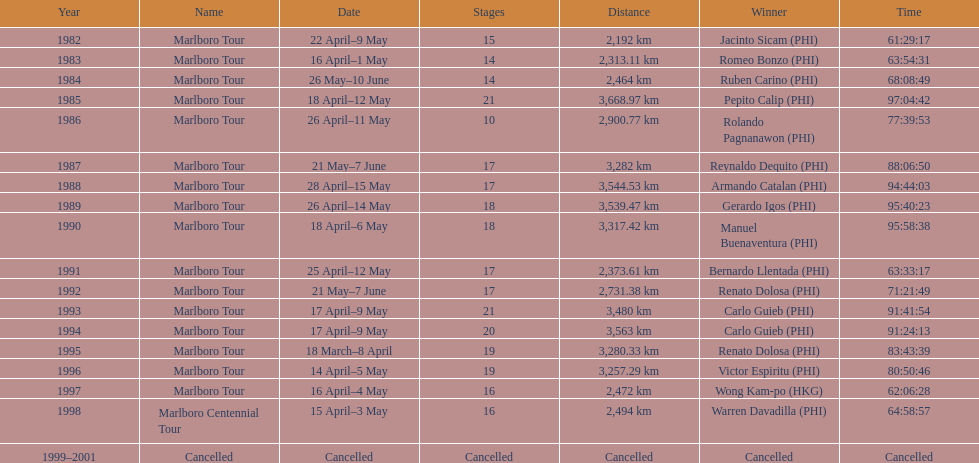Who achieved the most wins in marlboro tours? Carlo Guieb. Can you parse all the data within this table? {'header': ['Year', 'Name', 'Date', 'Stages', 'Distance', 'Winner', 'Time'], 'rows': [['1982', 'Marlboro Tour', '22 April–9 May', '15', '2,192\xa0km', 'Jacinto Sicam\xa0(PHI)', '61:29:17'], ['1983', 'Marlboro Tour', '16 April–1 May', '14', '2,313.11\xa0km', 'Romeo Bonzo\xa0(PHI)', '63:54:31'], ['1984', 'Marlboro Tour', '26 May–10 June', '14', '2,464\xa0km', 'Ruben Carino\xa0(PHI)', '68:08:49'], ['1985', 'Marlboro Tour', '18 April–12 May', '21', '3,668.97\xa0km', 'Pepito Calip\xa0(PHI)', '97:04:42'], ['1986', 'Marlboro Tour', '26 April–11 May', '10', '2,900.77\xa0km', 'Rolando Pagnanawon\xa0(PHI)', '77:39:53'], ['1987', 'Marlboro Tour', '21 May–7 June', '17', '3,282\xa0km', 'Reynaldo Dequito\xa0(PHI)', '88:06:50'], ['1988', 'Marlboro Tour', '28 April–15 May', '17', '3,544.53\xa0km', 'Armando Catalan\xa0(PHI)', '94:44:03'], ['1989', 'Marlboro Tour', '26 April–14 May', '18', '3,539.47\xa0km', 'Gerardo Igos\xa0(PHI)', '95:40:23'], ['1990', 'Marlboro Tour', '18 April–6 May', '18', '3,317.42\xa0km', 'Manuel Buenaventura\xa0(PHI)', '95:58:38'], ['1991', 'Marlboro Tour', '25 April–12 May', '17', '2,373.61\xa0km', 'Bernardo Llentada\xa0(PHI)', '63:33:17'], ['1992', 'Marlboro Tour', '21 May–7 June', '17', '2,731.38\xa0km', 'Renato Dolosa\xa0(PHI)', '71:21:49'], ['1993', 'Marlboro Tour', '17 April–9 May', '21', '3,480\xa0km', 'Carlo Guieb\xa0(PHI)', '91:41:54'], ['1994', 'Marlboro Tour', '17 April–9 May', '20', '3,563\xa0km', 'Carlo Guieb\xa0(PHI)', '91:24:13'], ['1995', 'Marlboro Tour', '18 March–8 April', '19', '3,280.33\xa0km', 'Renato Dolosa\xa0(PHI)', '83:43:39'], ['1996', 'Marlboro Tour', '14 April–5 May', '19', '3,257.29\xa0km', 'Victor Espiritu\xa0(PHI)', '80:50:46'], ['1997', 'Marlboro Tour', '16 April–4 May', '16', '2,472\xa0km', 'Wong Kam-po\xa0(HKG)', '62:06:28'], ['1998', 'Marlboro Centennial Tour', '15 April–3 May', '16', '2,494\xa0km', 'Warren Davadilla\xa0(PHI)', '64:58:57'], ['1999–2001', 'Cancelled', 'Cancelled', 'Cancelled', 'Cancelled', 'Cancelled', 'Cancelled']]} 